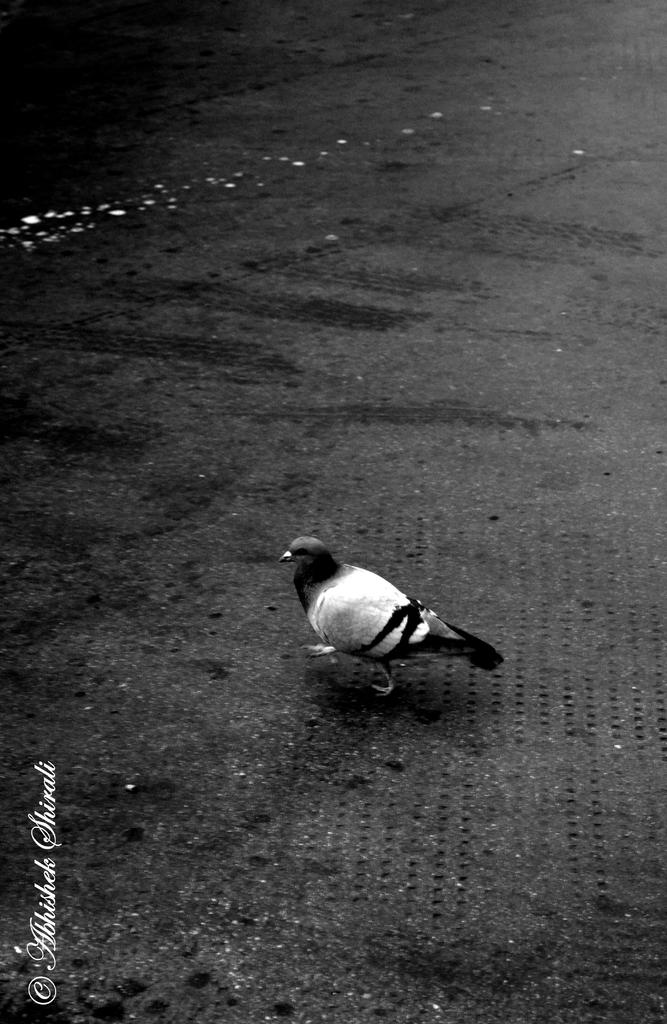What is present on the road in the image? There is a bird on the road in the image. Is there any text or writing in the image? Yes, there is text or writing at the bottom left side of the image. How does the bird smell in the image? The image does not provide information about the bird's smell, so it cannot be determined from the image. 